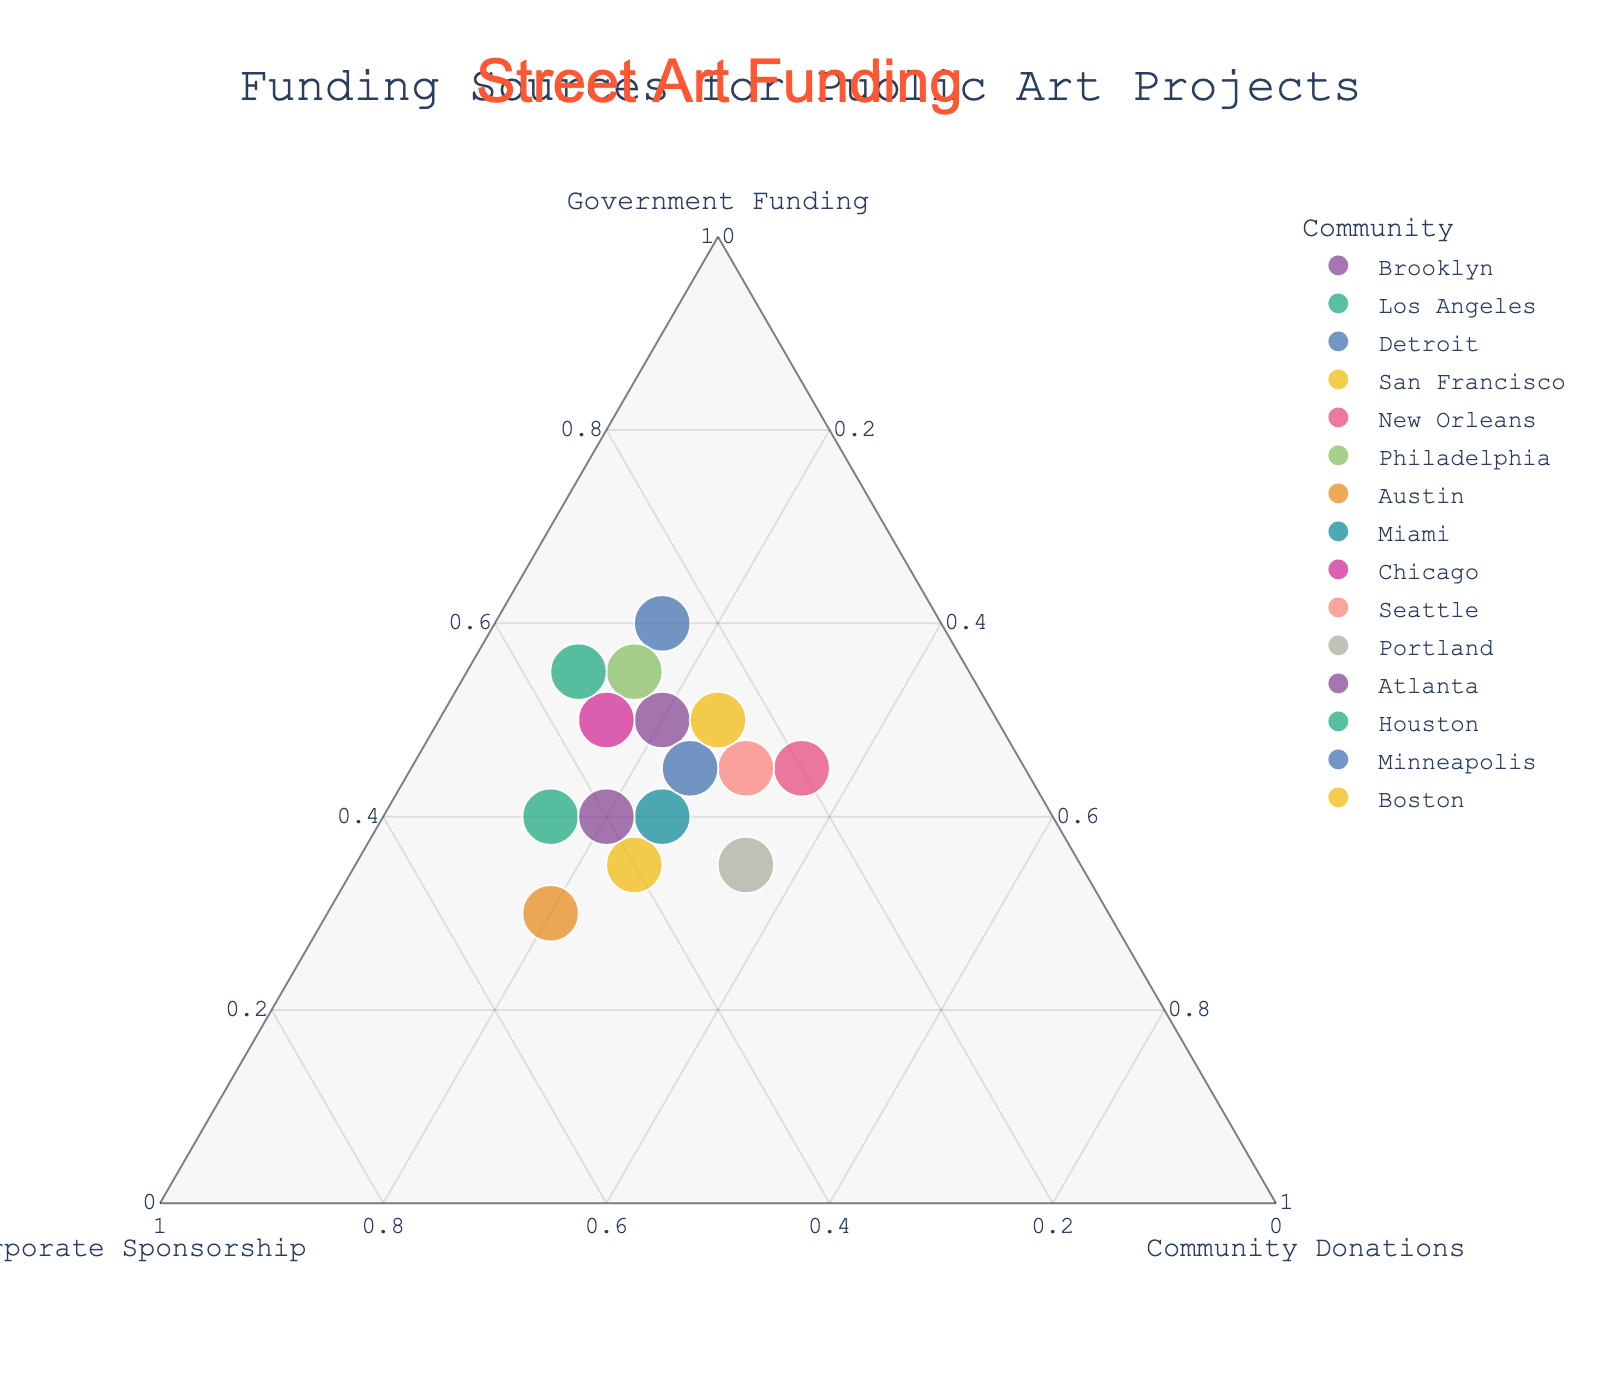What is the title of the figure? The title of the figure is usually found at the top and labels the main topic of the chart.
Answer: "Funding Sources for Public Art Projects" How many communities are represented in the ternary plot? Count the number of distinct data points each labeled with a community name.
Answer: 15 Which community relies the least on community donations? Identify the point closest to the axis labeled "Community Donations."
Answer: Houston Which community has the highest percentage of corporate sponsorship? Identify the point closest to the axis labeled "Corporate Sponsorship."
Answer: Austin Which community has an equal proportion of government funding and community donations? Locate the point along the line where government funding equals community donations.
Answer: Boston What is the axis label for the top vertex of the ternary plot? The top vertex of plots typically represents one of the three variables.
Answer: "Government Funding" Which communities have roughly the same amount of funding from government and corporate sponsors but different community donations? Look for points on the plot that align vertically, indicating similar proportions in two axes but differing in the third.
Answer: Portland and Seattle How does the proportion of government funding compare between Brooklyn and Chicago? Compare the positioning of Brooklyn and Chicago along the "Government Funding" axis.
Answer: Similar; both have 50% government funding Which community has approximately equal funding from all three sources? Find a point near the center of the ternary plot where all three contributions are roughly equal.
Answer: Portland What color represents San Francisco in the ternary plot? Identify the community and then refer to its color representation on the plot.
Answer: Varies, often color-coded; needs specific chart view to determine exact color 